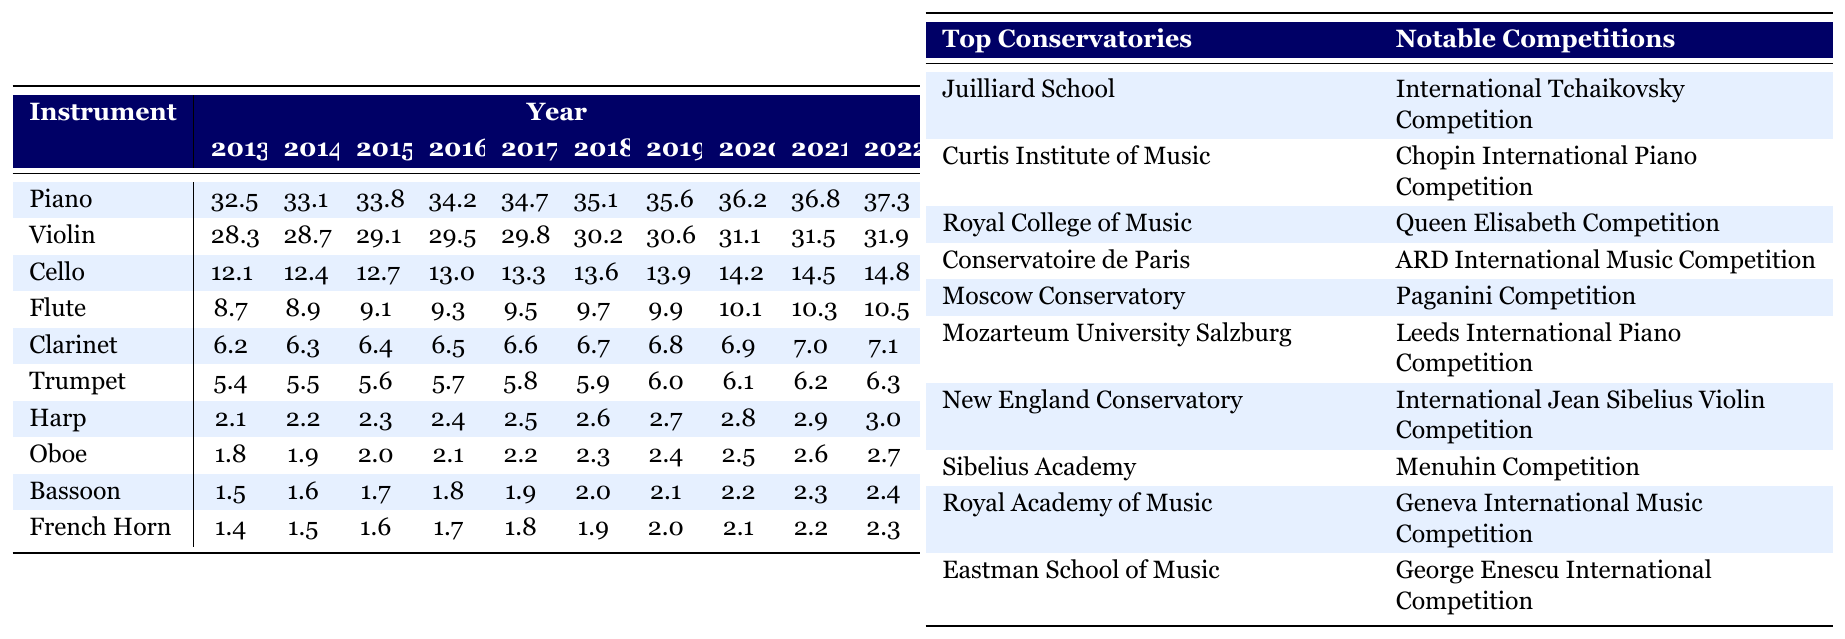What was the percentage popularity of the piano in 2022? In the table, we locate the row for piano and the column for the year 2022. The value is 37.3, indicating that the percentage popularity of the piano in 2022 was 37.3%.
Answer: 37.3% Which instrument had the highest percentage popularity in 2019? Looking at the year 2019 across all instruments, piano has the highest value at 35.6, while violin is next at 30.6. Comparing the values reveals that piano was the most popular instrument in 2019.
Answer: Piano What is the difference in popularity between the cello in 2022 and the oboe in 2022? For cello, the 2022 value is 14.8, and for oboe, it is 2.7. The difference is calculated as 14.8 - 2.7 = 12.1.
Answer: 12.1 Did the popularity of the flute ever exceed 10% in the past decade? Observing the flute row from 2013 to 2022, the values consistently increased from 8.7 in 2013 to 10.5 in 2022, confirming that it exceeded 10% for the first time in 2022.
Answer: Yes What trend can be observed in the popularity of the trumpet from 2013 to 2022? Analyzing the trumpet values from 5.4 in 2013 to 6.3 in 2022, we can observe a steady increase in popularity over the decade, rising each year.
Answer: Increasing What is the average popularity of all string instruments in 2022? The string instruments are piano (37.3), violin (31.9), cello (14.8), and harp (3.0). Adding these gives 37.3 + 31.9 + 14.8 + 3.0 = 87.0. Dividing by 4 yields an average of 21.75.
Answer: 21.75 In which year did the clarinet reach 6.8% popularity? Checking the clarinet row, the value of 6.8 is found in the year 2019, confirming that it had 6.8% popularity that year.
Answer: 2019 What was the total popularity percentage of all woodwind instruments in 2020? The woodwind instruments observed are flute (10.1), clarinet (6.9), oboe (2.5), bassoon (2.2), and French horn (2.1). Adding these values gives 10.1 + 6.9 + 2.5 + 2.2 + 2.1 = 24.8.
Answer: 24.8 Which instrument saw the smallest percentage increase from 2013 to 2022? Evaluating the percentage increases: Cello: 14.8 - 12.1 = 2.7; Clarinet: 7.1 - 6.2 = 0.9; Trumpet: 6.3 - 5.4 = 0.9; others show larger increases. Both clarinet and trumpet saw a 0.9 increase, making them the smallest.
Answer: Clarinet and Trumpet What is the relationship between the top conservatories and their notable competitions regarding the trend in instrument popularity? The relationship shows that high-renowned conservatories correspond with notable competitions, typically favoring string and piano disciplines, aligning with the data indicating increasing popularity for these instruments.
Answer: Positive relationship 